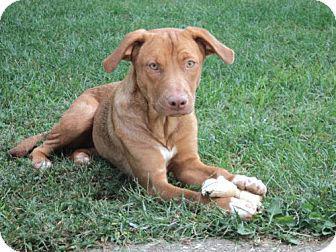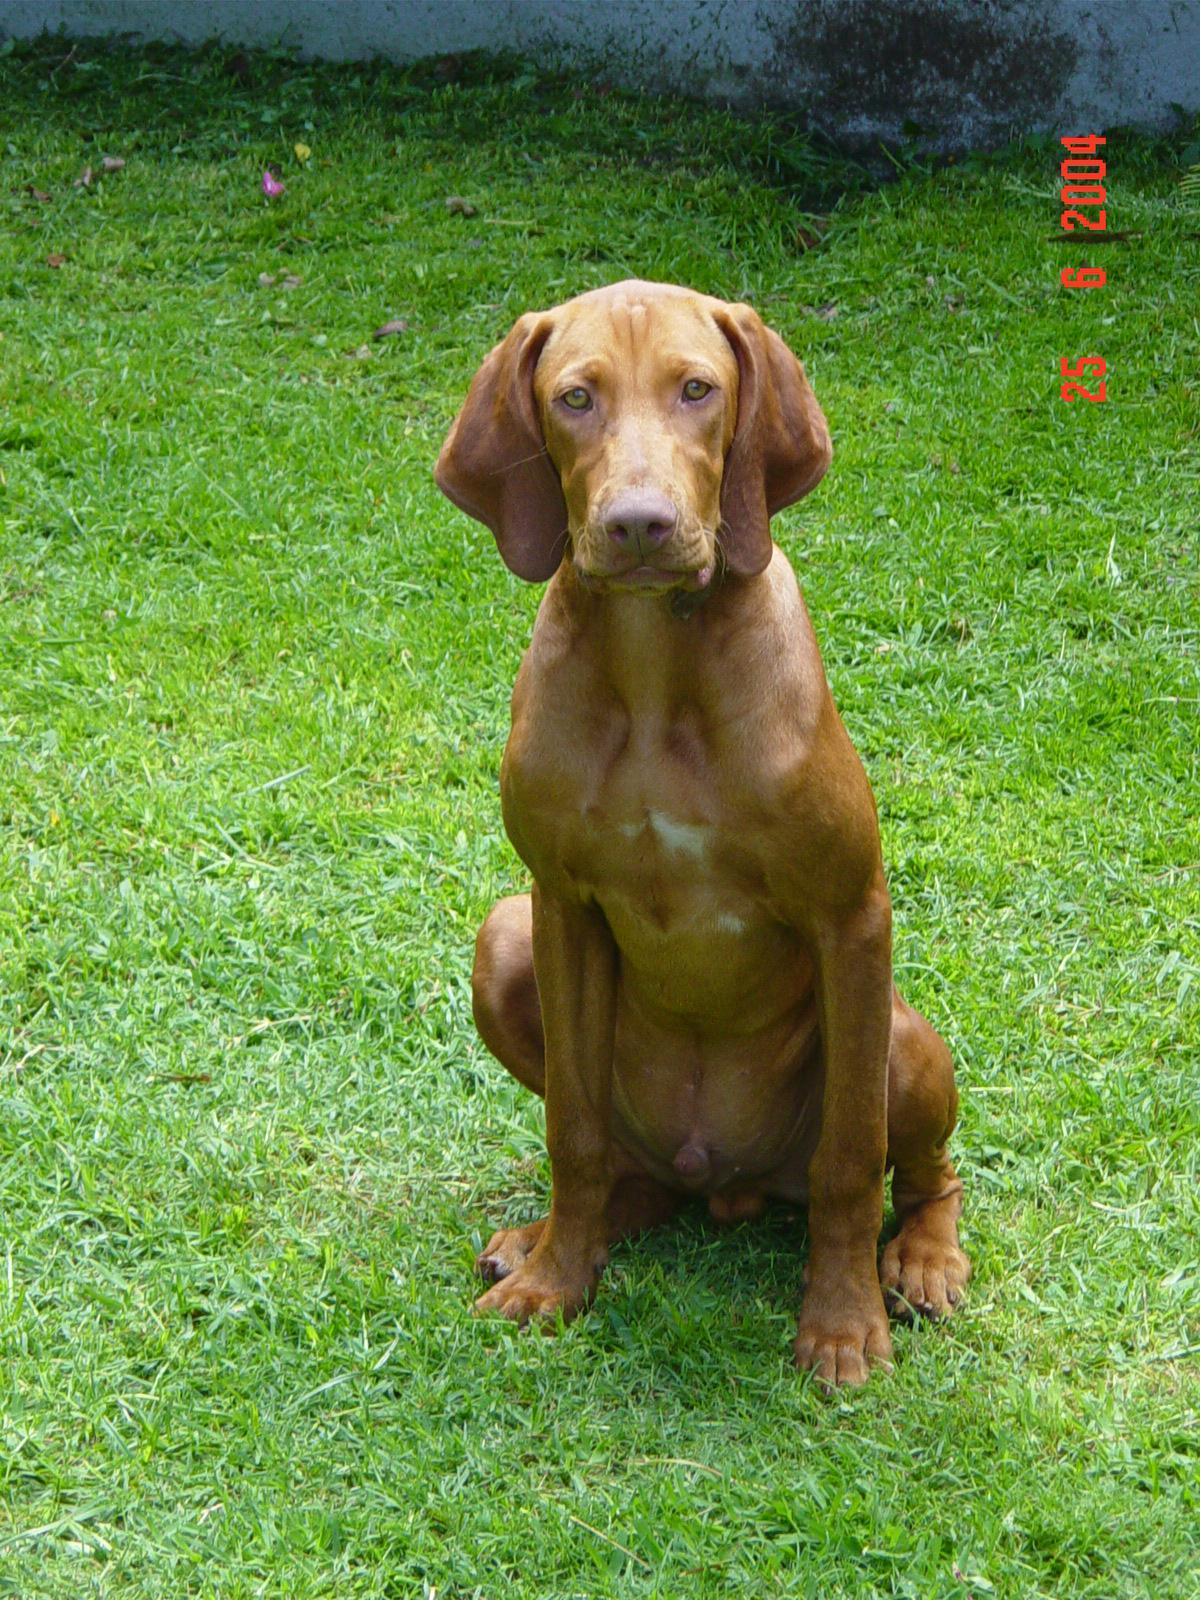The first image is the image on the left, the second image is the image on the right. Analyze the images presented: Is the assertion "In one of the images, there is a brown dog that is lying in the grass." valid? Answer yes or no. Yes. 